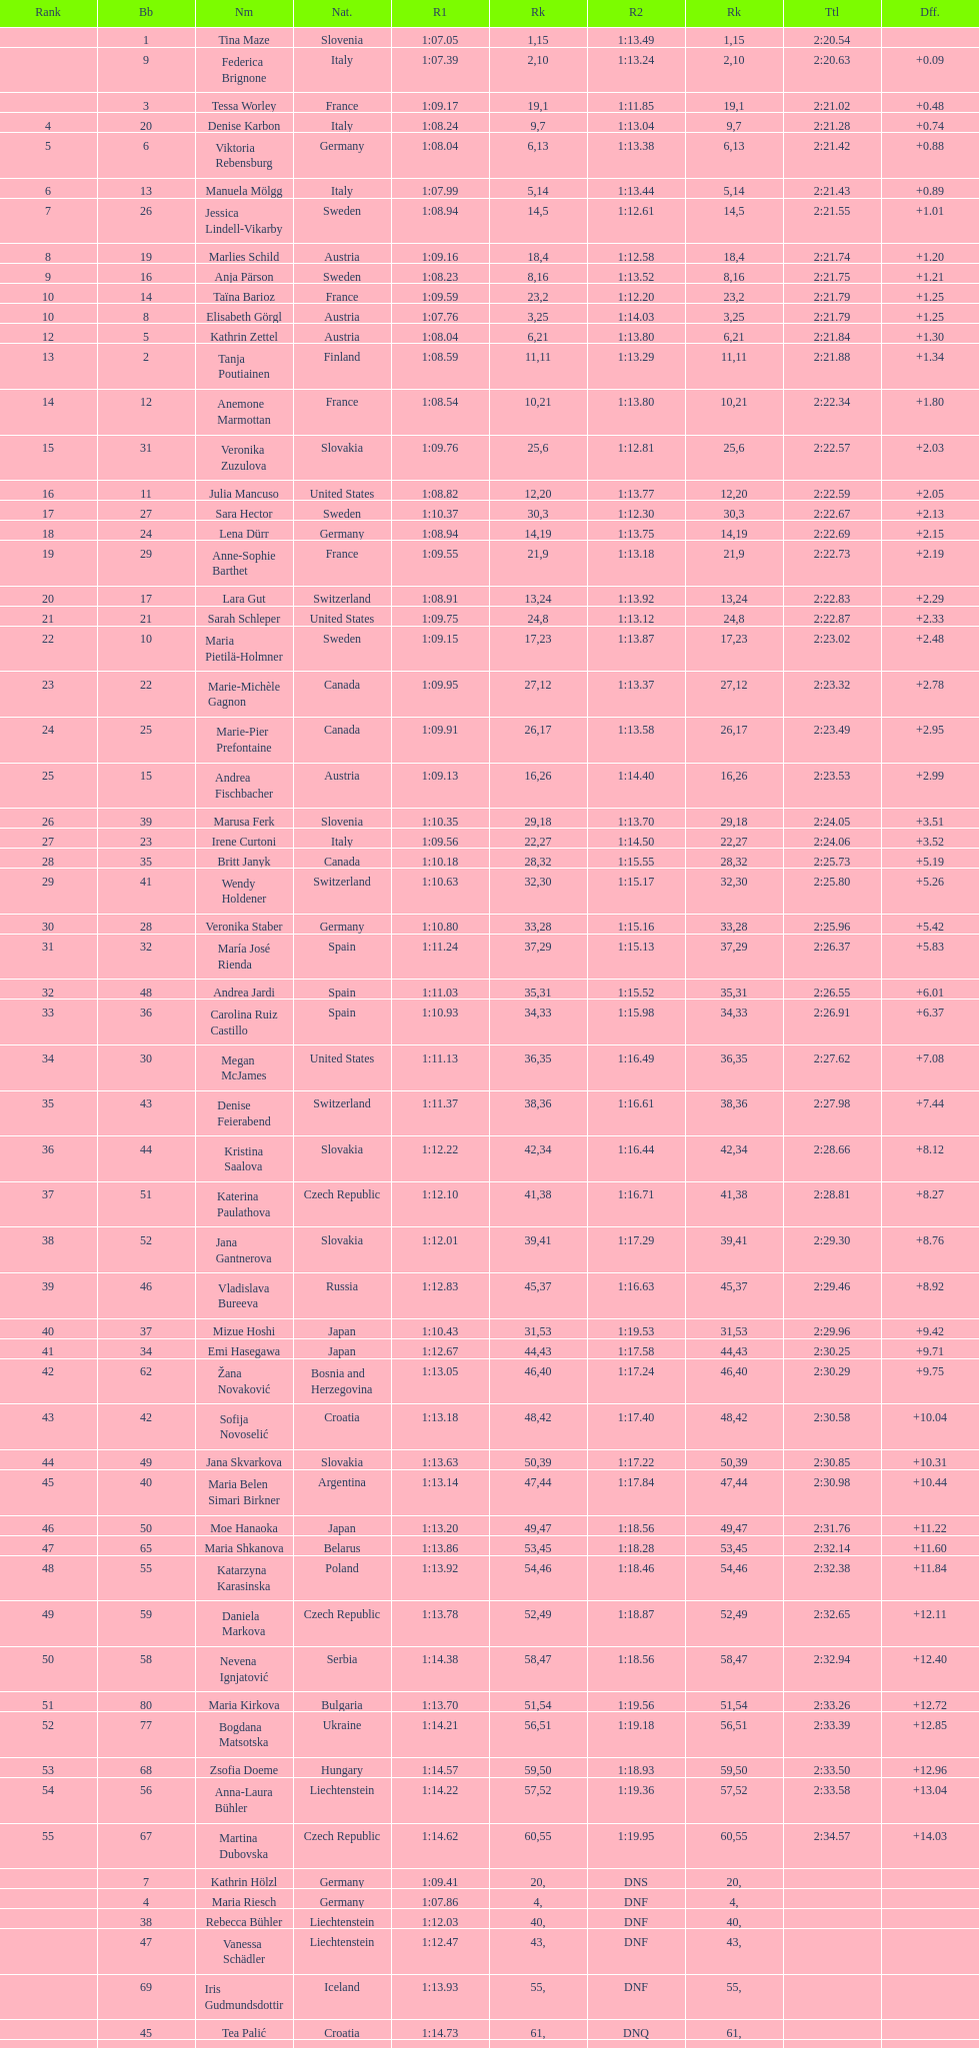What was the number of swedes in the top fifteen? 2. 